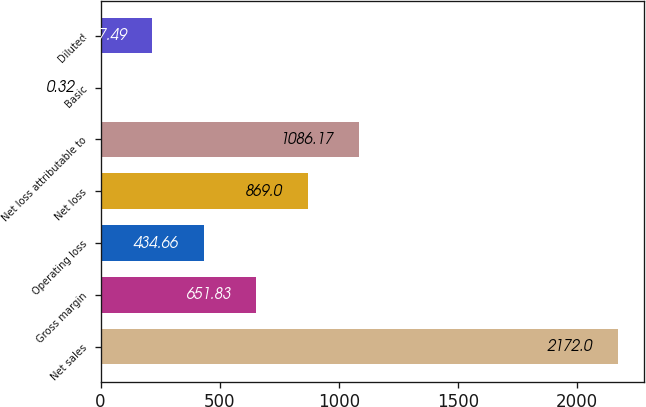Convert chart to OTSL. <chart><loc_0><loc_0><loc_500><loc_500><bar_chart><fcel>Net sales<fcel>Gross margin<fcel>Operating loss<fcel>Net loss<fcel>Net loss attributable to<fcel>Basic<fcel>Diluted<nl><fcel>2172<fcel>651.83<fcel>434.66<fcel>869<fcel>1086.17<fcel>0.32<fcel>217.49<nl></chart> 